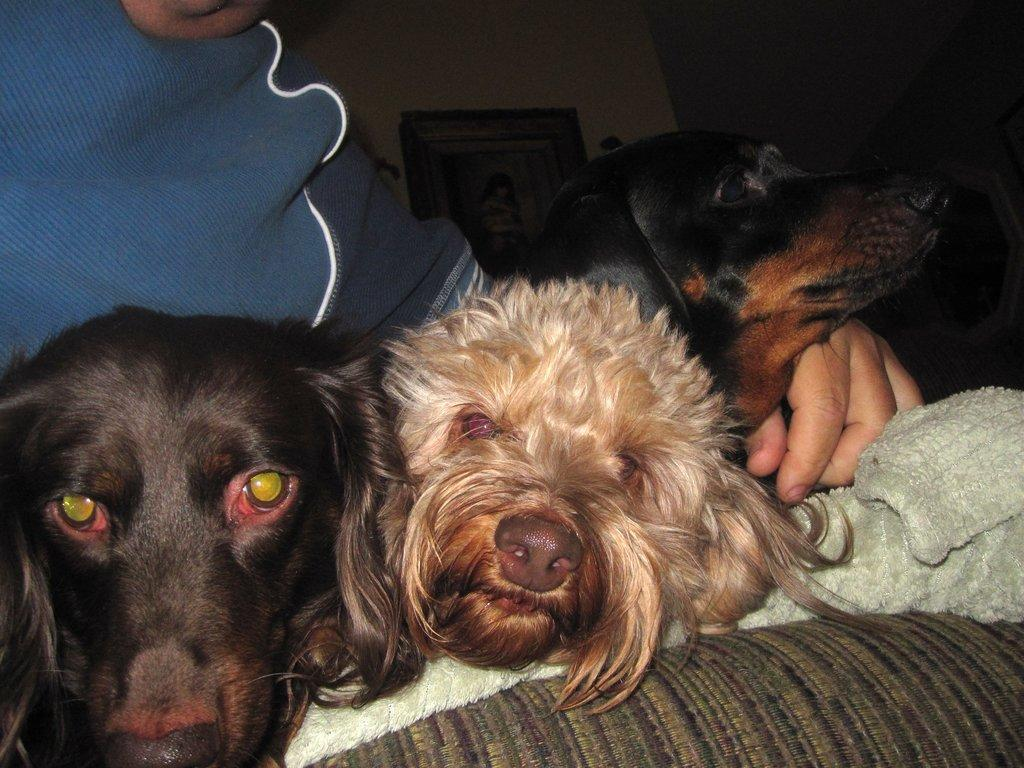How many dogs are present in the image? There are three dogs in the image. What is the person in the image doing? The person is sitting on a sofa in the image. Can you describe any decorative elements in the background of the image? There is a photo frame hanging on the wall in the background of the image. What type of shoes is the giraffe wearing in the image? There is no giraffe present in the image, and therefore no shoes to describe. 